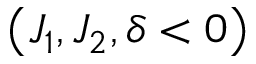Convert formula to latex. <formula><loc_0><loc_0><loc_500><loc_500>\left ( J _ { 1 } , J _ { 2 } , \delta < 0 \right )</formula> 